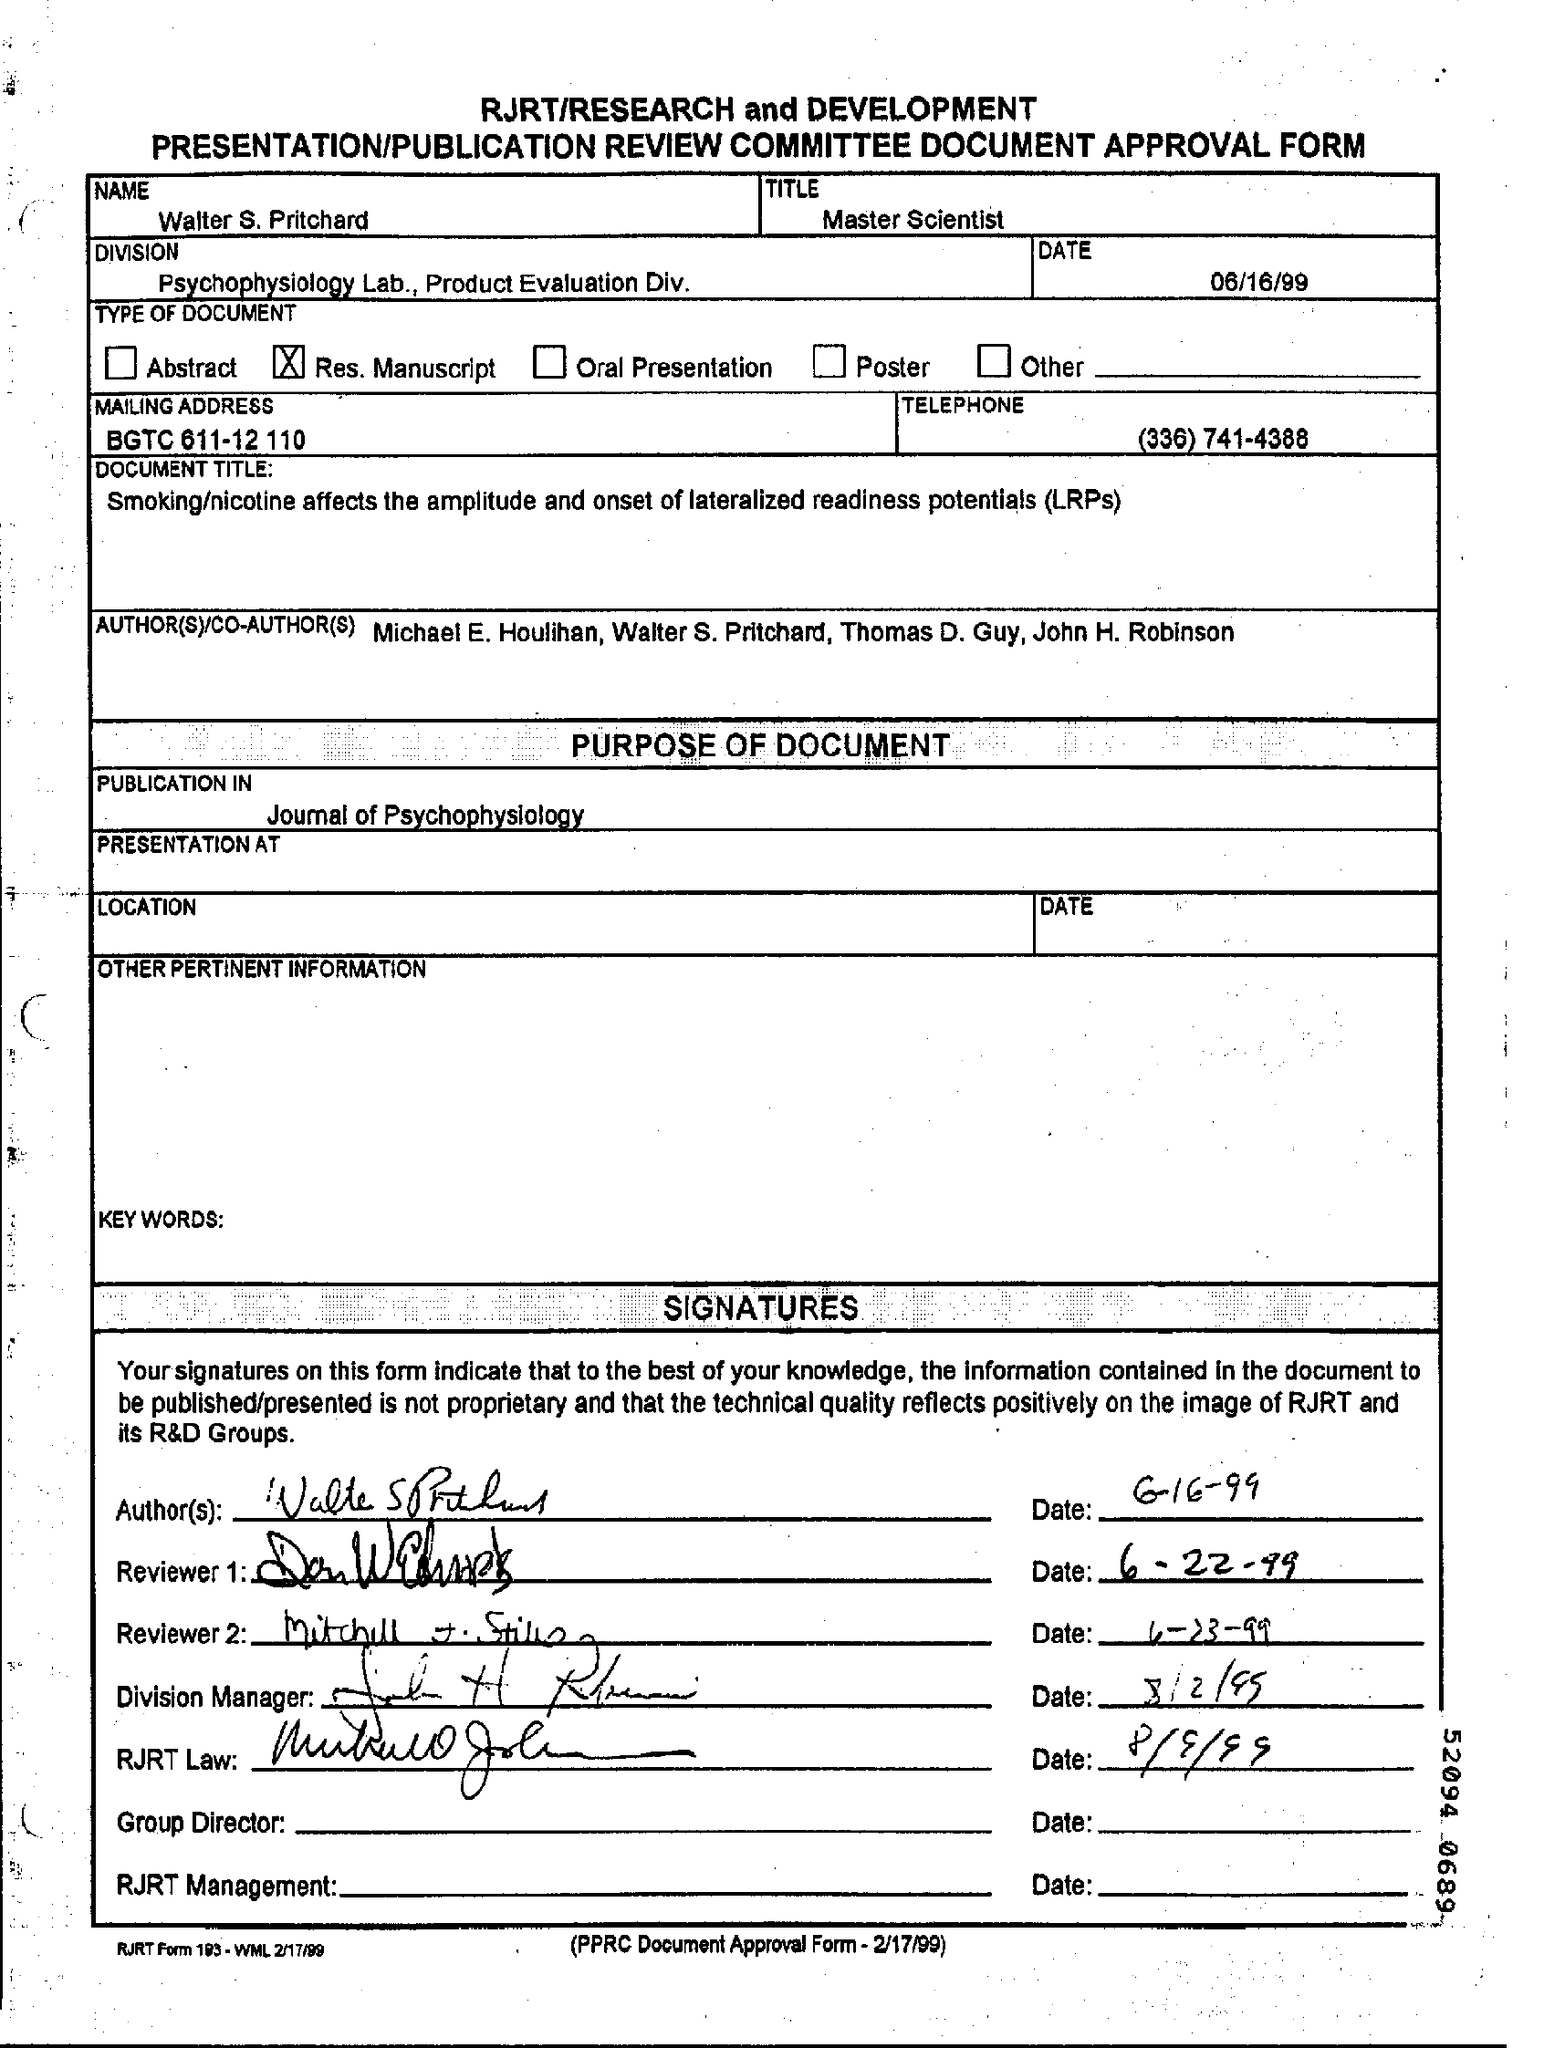Indicate a few pertinent items in this graphic. The name written in the form is "Walter S. Pritchard. The date on which Reviewer 1 signed the document is June 22, 1999. The date mentioned on the form is June 16th, 1999. The Division field contains the text "Psychophysiology Lab., Product Evaluation Division. The title field contains the written phrase 'Master Scientist.' 